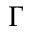Convert formula to latex. <formula><loc_0><loc_0><loc_500><loc_500>\Gamma</formula> 